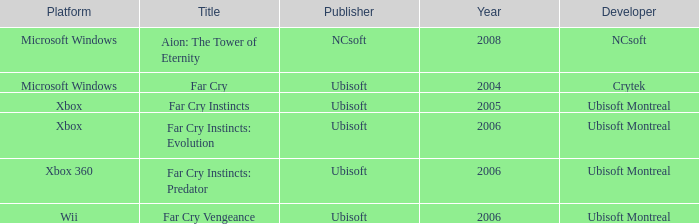Which title has a year prior to 2008 and xbox 360 as the platform? Far Cry Instincts: Predator. 